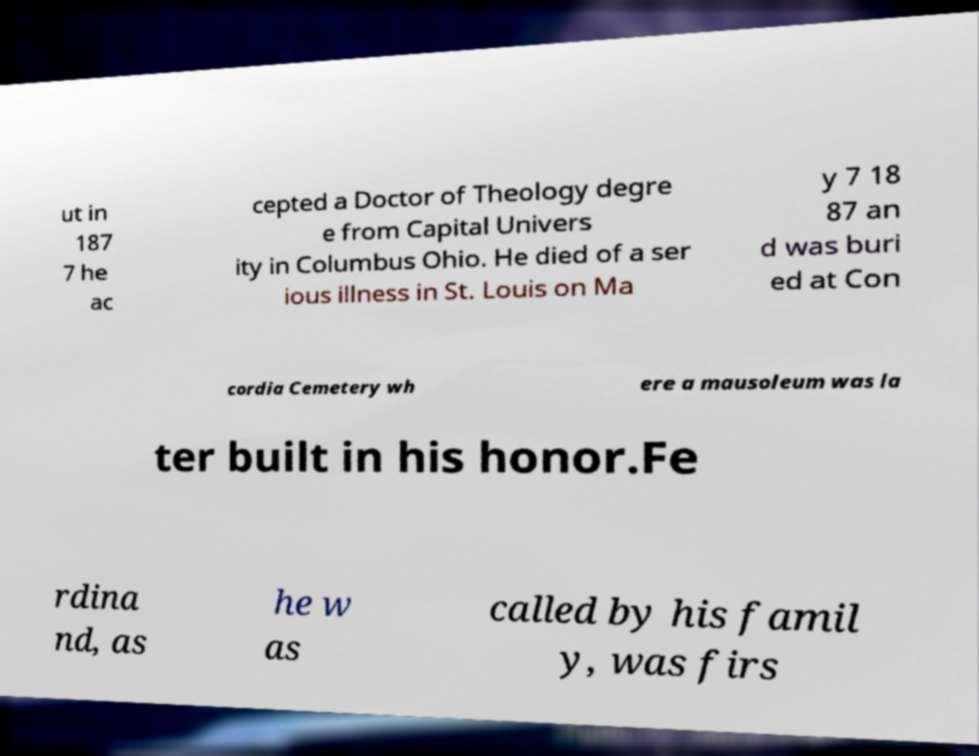For documentation purposes, I need the text within this image transcribed. Could you provide that? ut in 187 7 he ac cepted a Doctor of Theology degre e from Capital Univers ity in Columbus Ohio. He died of a ser ious illness in St. Louis on Ma y 7 18 87 an d was buri ed at Con cordia Cemetery wh ere a mausoleum was la ter built in his honor.Fe rdina nd, as he w as called by his famil y, was firs 